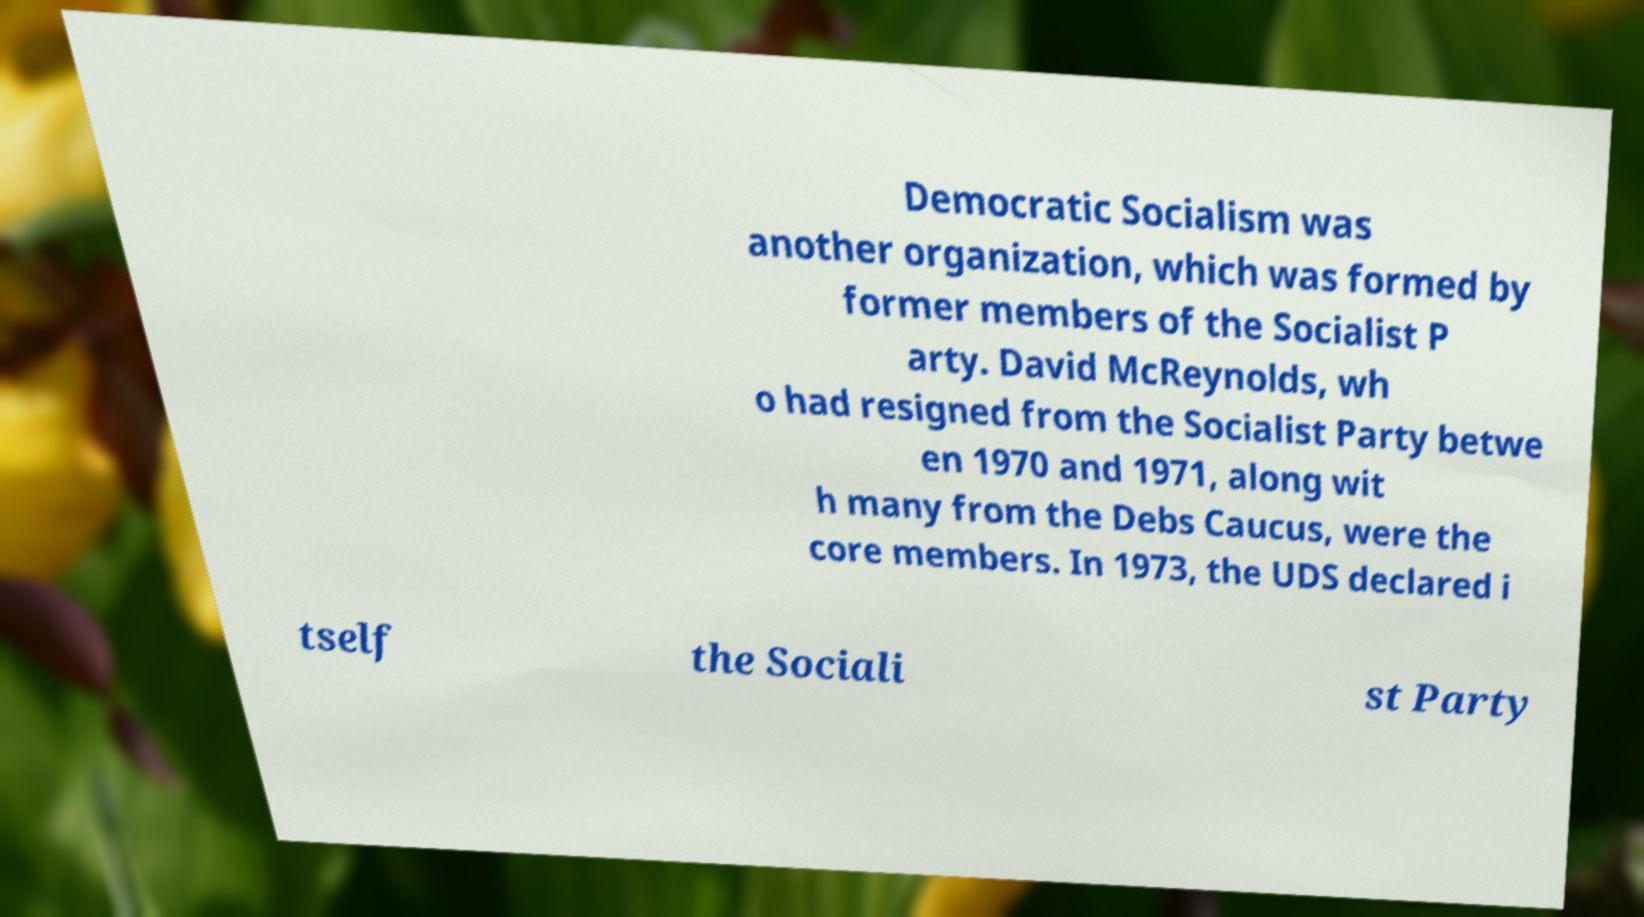Could you assist in decoding the text presented in this image and type it out clearly? Democratic Socialism was another organization, which was formed by former members of the Socialist P arty. David McReynolds, wh o had resigned from the Socialist Party betwe en 1970 and 1971, along wit h many from the Debs Caucus, were the core members. In 1973, the UDS declared i tself the Sociali st Party 